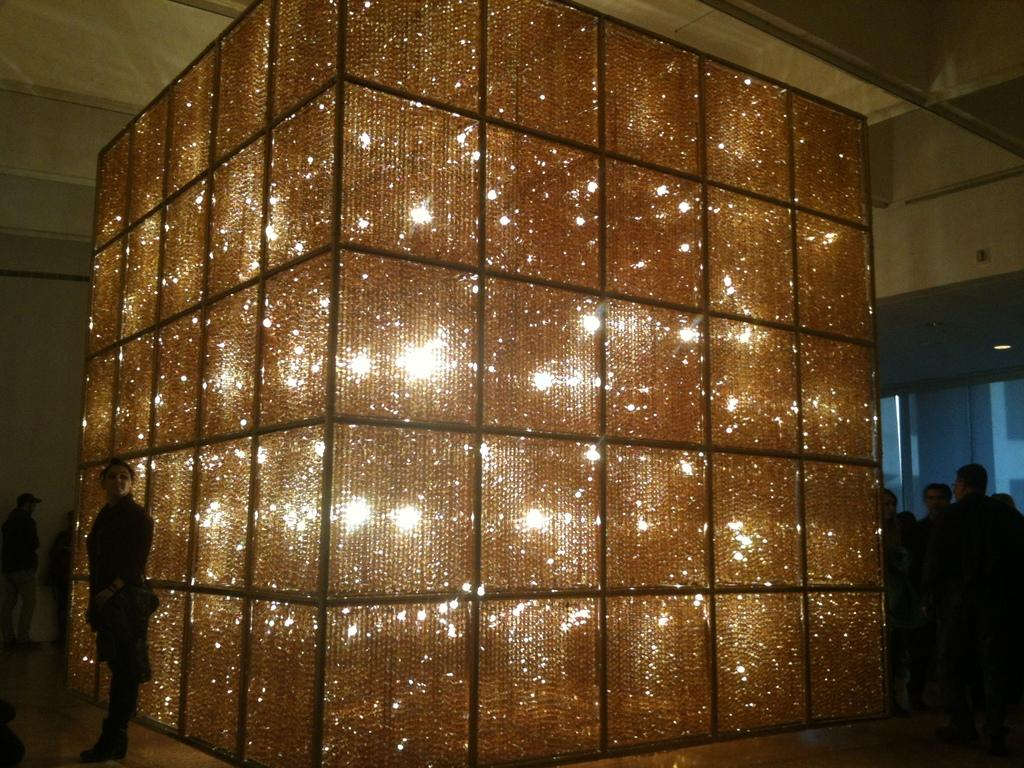What is the main object in the foreground of the image? There is a square-shaped box with lights in the foreground of the image. What are the people in the image doing? The people are standing around the box. What can be seen in the background of the image? There is a glass window and a ceiling visible in the background of the image. What type of soup is being served in the image? There is no soup present in the image. What structure is holding the brake in the image? There is no brake or structure holding a brake in the image. 